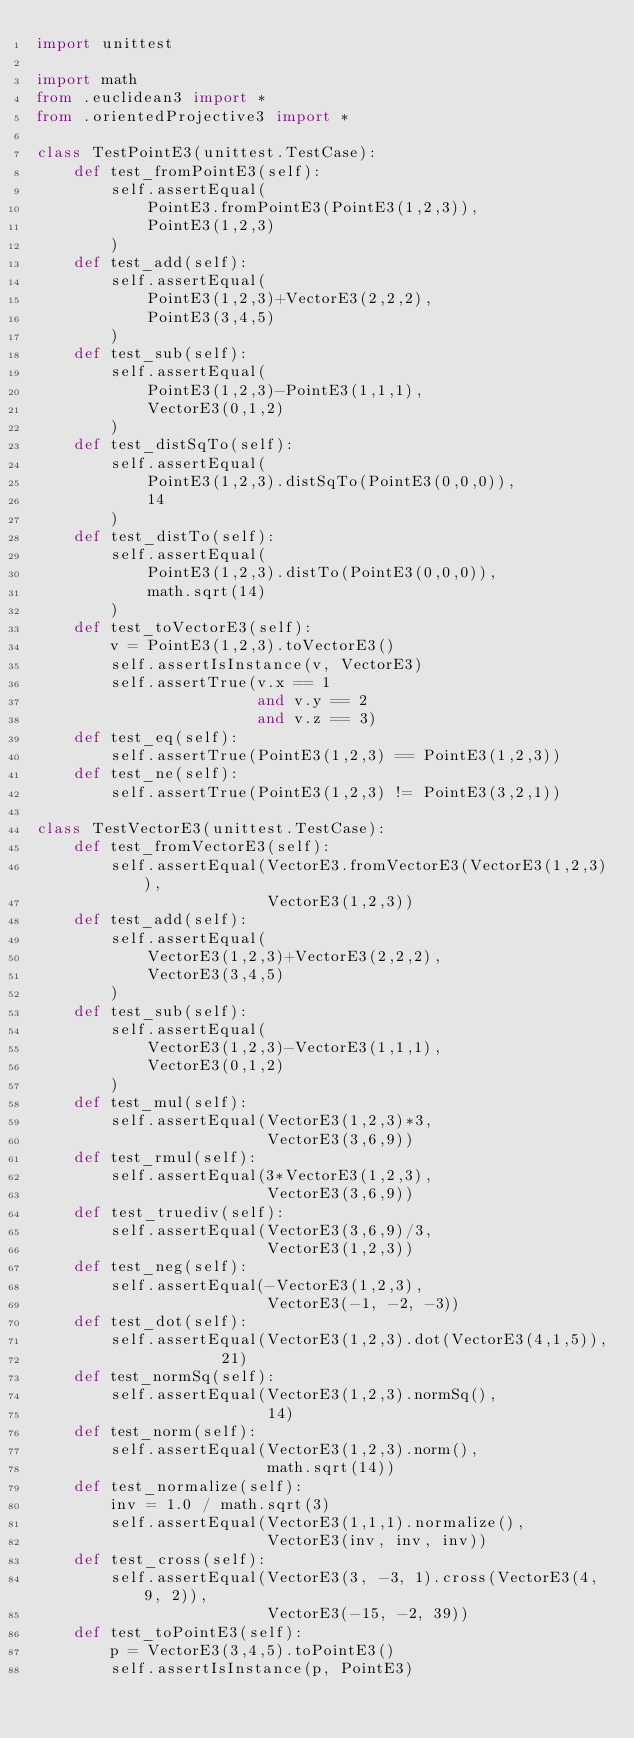<code> <loc_0><loc_0><loc_500><loc_500><_Python_>import unittest

import math
from .euclidean3 import *
from .orientedProjective3 import *

class TestPointE3(unittest.TestCase):
    def test_fromPointE3(self):
        self.assertEqual(
            PointE3.fromPointE3(PointE3(1,2,3)),
            PointE3(1,2,3)
        )
    def test_add(self):
        self.assertEqual(
            PointE3(1,2,3)+VectorE3(2,2,2),
            PointE3(3,4,5)
        )
    def test_sub(self):
        self.assertEqual(
            PointE3(1,2,3)-PointE3(1,1,1),
            VectorE3(0,1,2)
        )
    def test_distSqTo(self):
        self.assertEqual(
            PointE3(1,2,3).distSqTo(PointE3(0,0,0)),
            14
        )
    def test_distTo(self):
        self.assertEqual(
            PointE3(1,2,3).distTo(PointE3(0,0,0)),
            math.sqrt(14)
        )
    def test_toVectorE3(self):
        v = PointE3(1,2,3).toVectorE3()
        self.assertIsInstance(v, VectorE3)
        self.assertTrue(v.x == 1
                        and v.y == 2
                        and v.z == 3)
    def test_eq(self):
        self.assertTrue(PointE3(1,2,3) == PointE3(1,2,3))
    def test_ne(self):
        self.assertTrue(PointE3(1,2,3) != PointE3(3,2,1))

class TestVectorE3(unittest.TestCase):
    def test_fromVectorE3(self):
        self.assertEqual(VectorE3.fromVectorE3(VectorE3(1,2,3)),
                         VectorE3(1,2,3))
    def test_add(self):
        self.assertEqual(
            VectorE3(1,2,3)+VectorE3(2,2,2),
            VectorE3(3,4,5)
        )
    def test_sub(self):
        self.assertEqual(
            VectorE3(1,2,3)-VectorE3(1,1,1),
            VectorE3(0,1,2)
        )
    def test_mul(self):
        self.assertEqual(VectorE3(1,2,3)*3,
                         VectorE3(3,6,9))
    def test_rmul(self):
        self.assertEqual(3*VectorE3(1,2,3),
                         VectorE3(3,6,9))
    def test_truediv(self):
        self.assertEqual(VectorE3(3,6,9)/3,
                         VectorE3(1,2,3))
    def test_neg(self):
        self.assertEqual(-VectorE3(1,2,3),
                         VectorE3(-1, -2, -3))
    def test_dot(self):
        self.assertEqual(VectorE3(1,2,3).dot(VectorE3(4,1,5)),
                    21)
    def test_normSq(self):
        self.assertEqual(VectorE3(1,2,3).normSq(),
                         14)
    def test_norm(self):
        self.assertEqual(VectorE3(1,2,3).norm(),
                         math.sqrt(14))
    def test_normalize(self):
        inv = 1.0 / math.sqrt(3)
        self.assertEqual(VectorE3(1,1,1).normalize(), 
                         VectorE3(inv, inv, inv))
    def test_cross(self):
        self.assertEqual(VectorE3(3, -3, 1).cross(VectorE3(4, 9, 2)), 
                         VectorE3(-15, -2, 39))
    def test_toPointE3(self):
        p = VectorE3(3,4,5).toPointE3()
        self.assertIsInstance(p, PointE3)</code> 